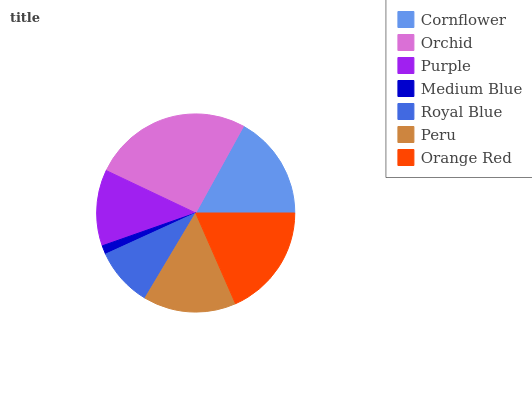Is Medium Blue the minimum?
Answer yes or no. Yes. Is Orchid the maximum?
Answer yes or no. Yes. Is Purple the minimum?
Answer yes or no. No. Is Purple the maximum?
Answer yes or no. No. Is Orchid greater than Purple?
Answer yes or no. Yes. Is Purple less than Orchid?
Answer yes or no. Yes. Is Purple greater than Orchid?
Answer yes or no. No. Is Orchid less than Purple?
Answer yes or no. No. Is Peru the high median?
Answer yes or no. Yes. Is Peru the low median?
Answer yes or no. Yes. Is Medium Blue the high median?
Answer yes or no. No. Is Royal Blue the low median?
Answer yes or no. No. 